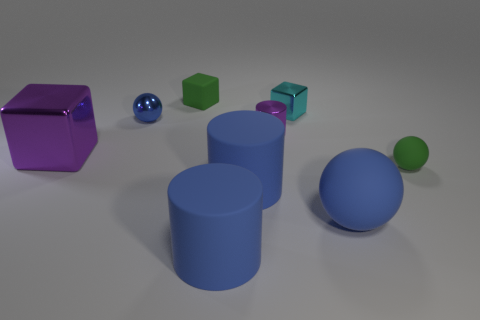Is there a large blue matte object on the right side of the green matte thing in front of the large purple metallic thing?
Offer a very short reply. No. There is a large object that is made of the same material as the small cyan cube; what is its shape?
Ensure brevity in your answer.  Cube. Is there any other thing that has the same color as the tiny matte sphere?
Make the answer very short. Yes. There is a large blue thing that is the same shape as the small blue thing; what is it made of?
Your answer should be compact. Rubber. What number of other objects are the same size as the shiny sphere?
Offer a very short reply. 4. What size is the metallic thing that is the same color as the tiny cylinder?
Keep it short and to the point. Large. There is a small matte object to the left of the tiny purple metallic cylinder; does it have the same shape as the big purple thing?
Make the answer very short. Yes. The small purple shiny object that is right of the big metallic object has what shape?
Provide a succinct answer. Cylinder. Is there a big cube that has the same material as the small purple thing?
Provide a short and direct response. Yes. Is the color of the small matte object to the right of the green block the same as the shiny ball?
Your answer should be compact. No. 